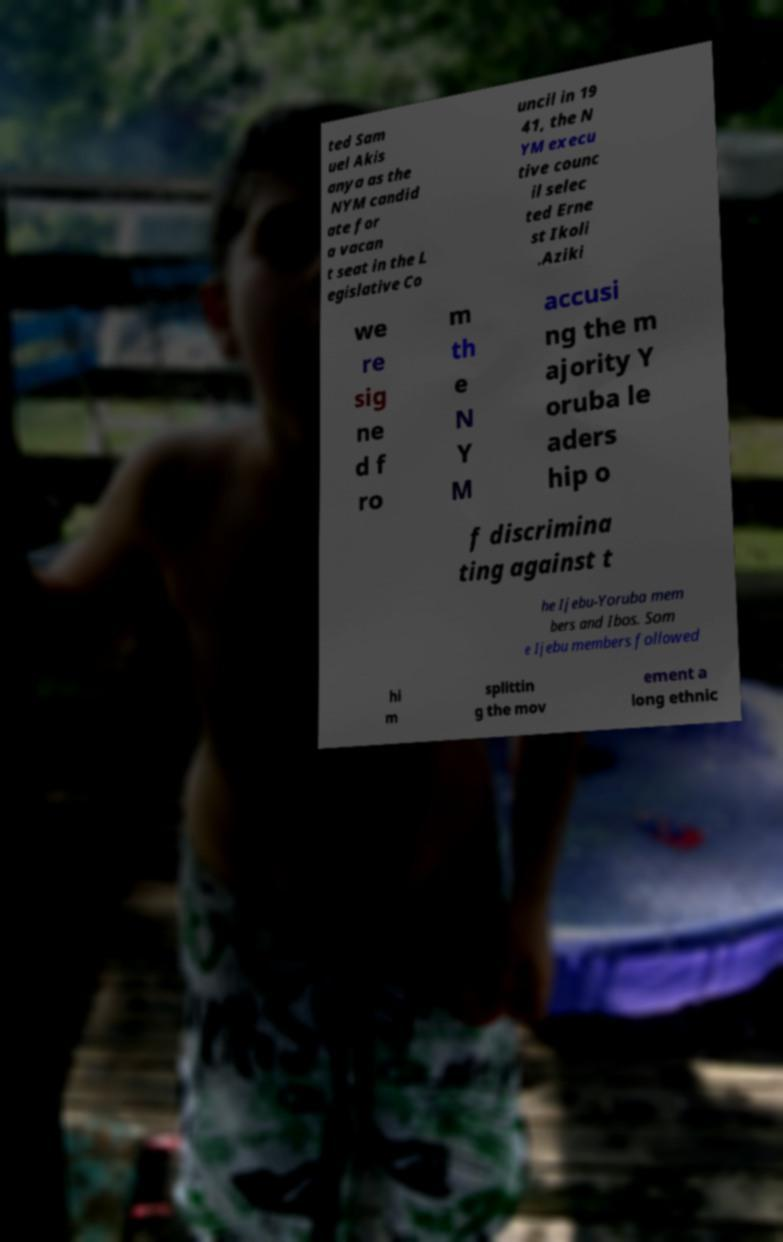Can you read and provide the text displayed in the image?This photo seems to have some interesting text. Can you extract and type it out for me? ted Sam uel Akis anya as the NYM candid ate for a vacan t seat in the L egislative Co uncil in 19 41, the N YM execu tive counc il selec ted Erne st Ikoli .Aziki we re sig ne d f ro m th e N Y M accusi ng the m ajority Y oruba le aders hip o f discrimina ting against t he Ijebu-Yoruba mem bers and Ibos. Som e Ijebu members followed hi m splittin g the mov ement a long ethnic 